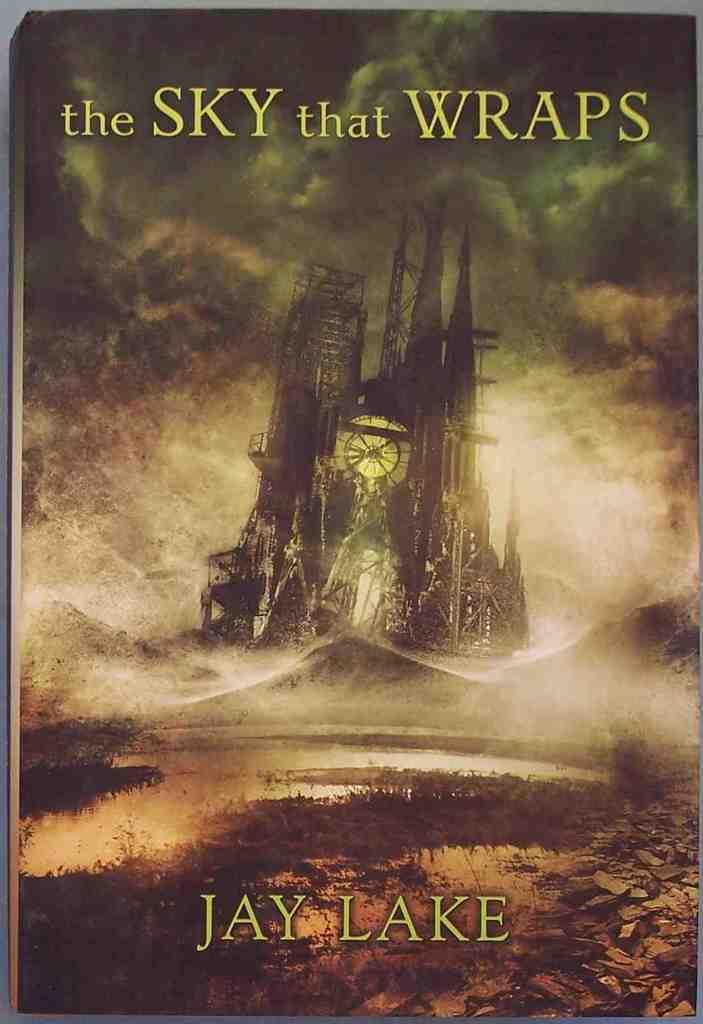Who authored the book?
Your answer should be very brief. Jay lake. Who's name is at the bottom of the book?
Offer a very short reply. Jay lake. 